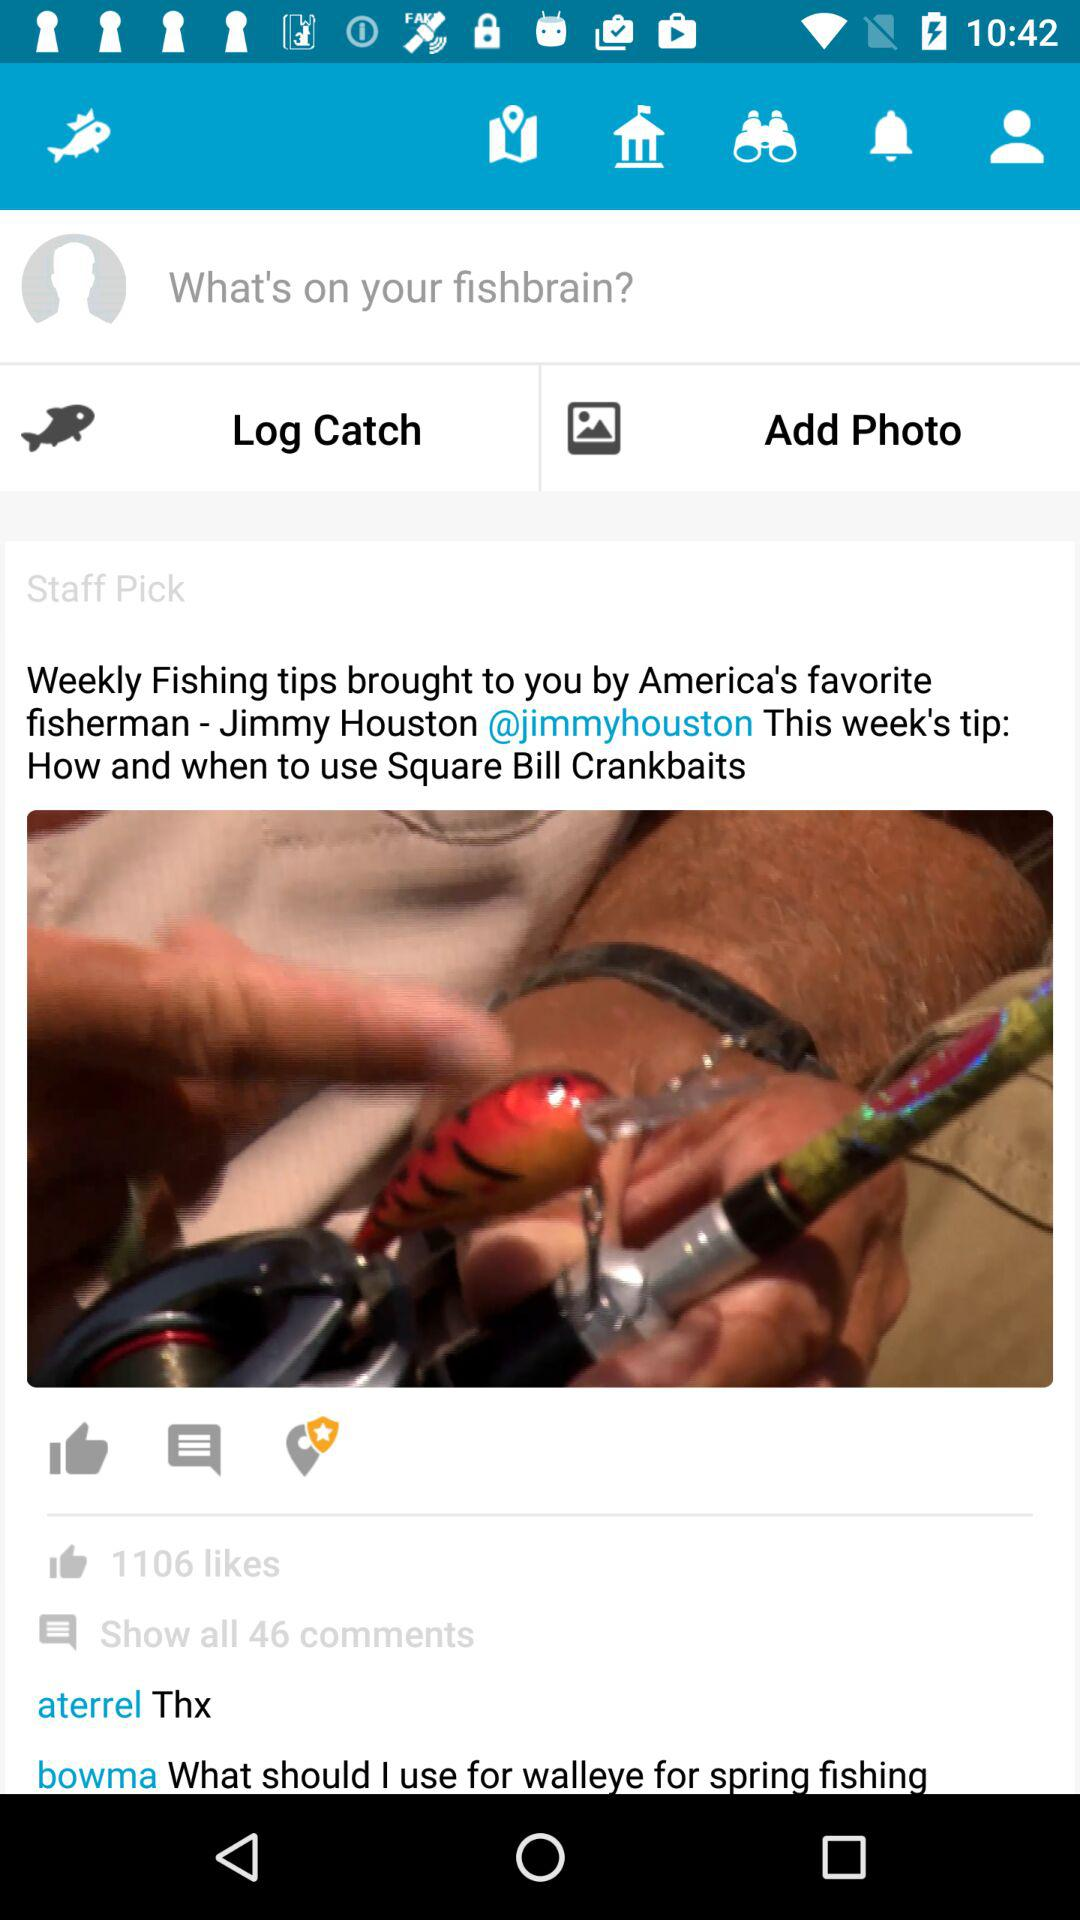How many comments are there on this post?
Answer the question using a single word or phrase. 46 